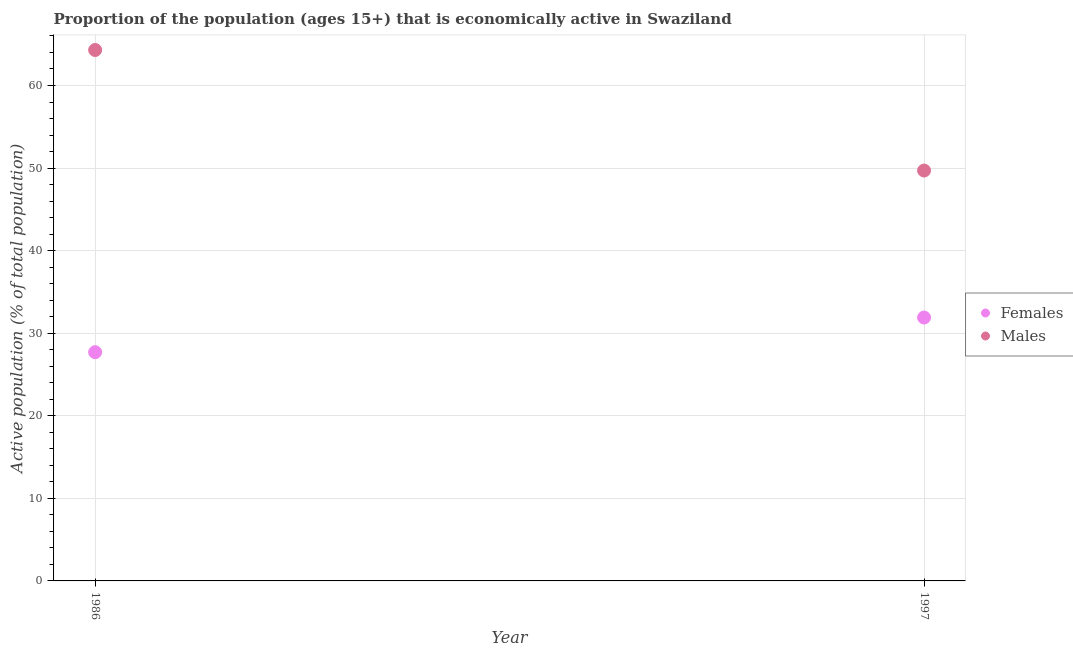How many different coloured dotlines are there?
Provide a short and direct response. 2. What is the percentage of economically active female population in 1997?
Offer a very short reply. 31.9. Across all years, what is the maximum percentage of economically active female population?
Keep it short and to the point. 31.9. Across all years, what is the minimum percentage of economically active female population?
Give a very brief answer. 27.7. In which year was the percentage of economically active male population maximum?
Ensure brevity in your answer.  1986. In which year was the percentage of economically active female population minimum?
Offer a terse response. 1986. What is the total percentage of economically active female population in the graph?
Your answer should be compact. 59.6. What is the difference between the percentage of economically active female population in 1986 and that in 1997?
Make the answer very short. -4.2. What is the difference between the percentage of economically active female population in 1997 and the percentage of economically active male population in 1986?
Offer a very short reply. -32.4. What is the average percentage of economically active male population per year?
Ensure brevity in your answer.  57. In the year 1986, what is the difference between the percentage of economically active male population and percentage of economically active female population?
Ensure brevity in your answer.  36.6. What is the ratio of the percentage of economically active female population in 1986 to that in 1997?
Offer a terse response. 0.87. Is the percentage of economically active male population in 1986 less than that in 1997?
Offer a very short reply. No. In how many years, is the percentage of economically active male population greater than the average percentage of economically active male population taken over all years?
Give a very brief answer. 1. Is the percentage of economically active male population strictly greater than the percentage of economically active female population over the years?
Offer a very short reply. Yes. How many dotlines are there?
Offer a very short reply. 2. How many years are there in the graph?
Ensure brevity in your answer.  2. Does the graph contain grids?
Your answer should be compact. Yes. Where does the legend appear in the graph?
Your answer should be compact. Center right. How are the legend labels stacked?
Offer a terse response. Vertical. What is the title of the graph?
Provide a succinct answer. Proportion of the population (ages 15+) that is economically active in Swaziland. What is the label or title of the X-axis?
Ensure brevity in your answer.  Year. What is the label or title of the Y-axis?
Your answer should be very brief. Active population (% of total population). What is the Active population (% of total population) of Females in 1986?
Keep it short and to the point. 27.7. What is the Active population (% of total population) in Males in 1986?
Provide a short and direct response. 64.3. What is the Active population (% of total population) in Females in 1997?
Your answer should be very brief. 31.9. What is the Active population (% of total population) of Males in 1997?
Your answer should be compact. 49.7. Across all years, what is the maximum Active population (% of total population) of Females?
Your answer should be compact. 31.9. Across all years, what is the maximum Active population (% of total population) of Males?
Your answer should be very brief. 64.3. Across all years, what is the minimum Active population (% of total population) in Females?
Your answer should be compact. 27.7. Across all years, what is the minimum Active population (% of total population) of Males?
Keep it short and to the point. 49.7. What is the total Active population (% of total population) of Females in the graph?
Provide a succinct answer. 59.6. What is the total Active population (% of total population) in Males in the graph?
Your response must be concise. 114. What is the difference between the Active population (% of total population) of Females in 1986 and that in 1997?
Provide a short and direct response. -4.2. What is the average Active population (% of total population) in Females per year?
Your answer should be very brief. 29.8. What is the average Active population (% of total population) of Males per year?
Your answer should be compact. 57. In the year 1986, what is the difference between the Active population (% of total population) in Females and Active population (% of total population) in Males?
Offer a terse response. -36.6. In the year 1997, what is the difference between the Active population (% of total population) of Females and Active population (% of total population) of Males?
Provide a succinct answer. -17.8. What is the ratio of the Active population (% of total population) of Females in 1986 to that in 1997?
Offer a terse response. 0.87. What is the ratio of the Active population (% of total population) in Males in 1986 to that in 1997?
Make the answer very short. 1.29. What is the difference between the highest and the second highest Active population (% of total population) of Females?
Your answer should be very brief. 4.2. What is the difference between the highest and the second highest Active population (% of total population) of Males?
Your response must be concise. 14.6. 